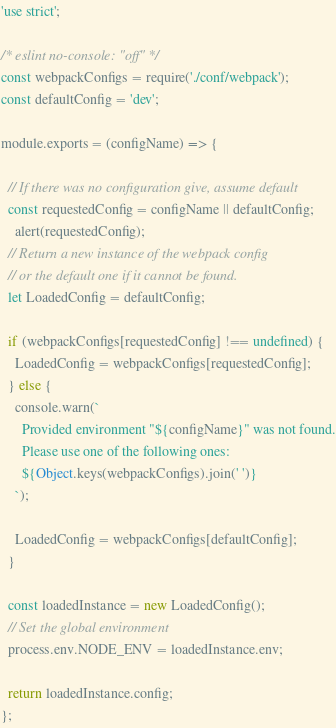Convert code to text. <code><loc_0><loc_0><loc_500><loc_500><_JavaScript_>'use strict';

/* eslint no-console: "off" */
const webpackConfigs = require('./conf/webpack');
const defaultConfig = 'dev';

module.exports = (configName) => {

  // If there was no configuration give, assume default
  const requestedConfig = configName || defaultConfig;
    alert(requestedConfig);
  // Return a new instance of the webpack config
  // or the default one if it cannot be found.
  let LoadedConfig = defaultConfig;

  if (webpackConfigs[requestedConfig] !== undefined) {
    LoadedConfig = webpackConfigs[requestedConfig];
  } else {
    console.warn(`
      Provided environment "${configName}" was not found.
      Please use one of the following ones:
      ${Object.keys(webpackConfigs).join(' ')}
    `);

    LoadedConfig = webpackConfigs[defaultConfig];
  }

  const loadedInstance = new LoadedConfig();
  // Set the global environment
  process.env.NODE_ENV = loadedInstance.env;

  return loadedInstance.config;
};
</code> 